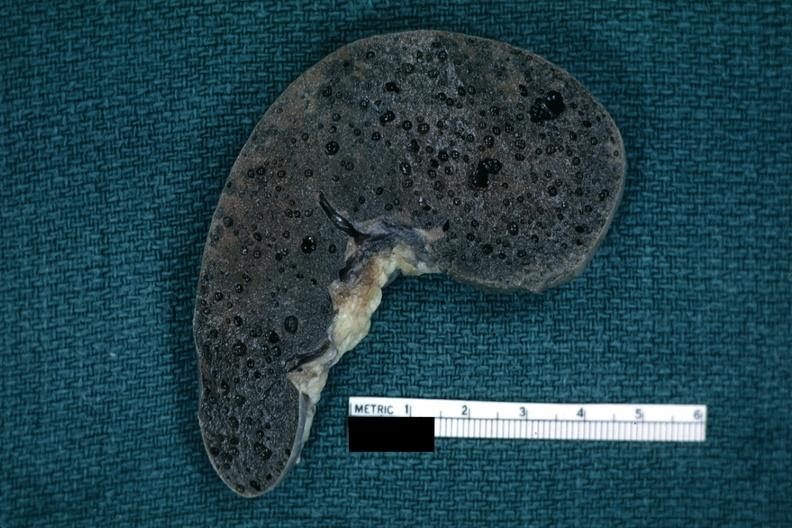s carcinoma superficial spreading present?
Answer the question using a single word or phrase. No 